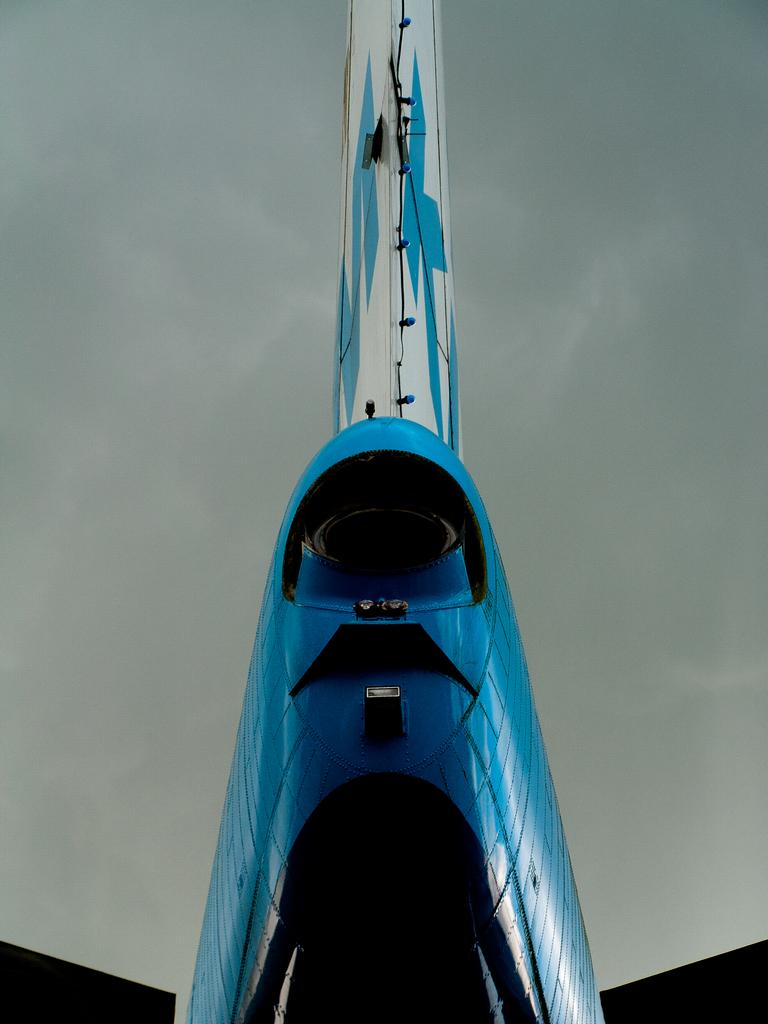What is the main subject in the foreground of the image? There is an object in the foreground of the image, but we cannot determine its specific nature from the given facts. What can be seen in the background of the image? The sky is visible in the background of the image. Can we determine the time of day when the image was taken? Yes, the image was likely taken during the day, as the sky is visible. How much debt is visible in the image? There is no mention of debt in the image, so we cannot determine its presence or amount. What type of wax can be seen melting in the image? There is no wax present in the image, so we cannot determine its type or state. 